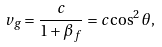Convert formula to latex. <formula><loc_0><loc_0><loc_500><loc_500>v _ { g } = \frac { c } { 1 + \beta _ { f } } = c \cos ^ { 2 } \theta ,</formula> 